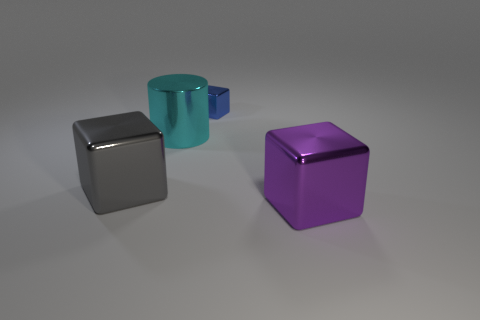How many objects are blocks that are in front of the small metal thing or metallic things?
Offer a very short reply. 4. The large metal thing in front of the large metal block to the left of the tiny cube is what shape?
Provide a short and direct response. Cube. Are there any gray metallic blocks that have the same size as the purple cube?
Make the answer very short. Yes. Is the number of big purple metallic cubes greater than the number of big shiny blocks?
Keep it short and to the point. No. Do the object that is behind the cyan cylinder and the purple metal thing right of the large cylinder have the same size?
Offer a terse response. No. How many metal objects are both to the right of the gray metallic thing and in front of the cyan metal object?
Your answer should be very brief. 1. The other big thing that is the same shape as the gray metallic thing is what color?
Your answer should be compact. Purple. Is the number of gray objects less than the number of big cyan rubber balls?
Ensure brevity in your answer.  No. There is a cyan thing; is its size the same as the metallic block behind the cyan cylinder?
Your answer should be compact. No. What color is the shiny cube that is behind the big shiny cube on the left side of the purple metallic block?
Offer a very short reply. Blue. 